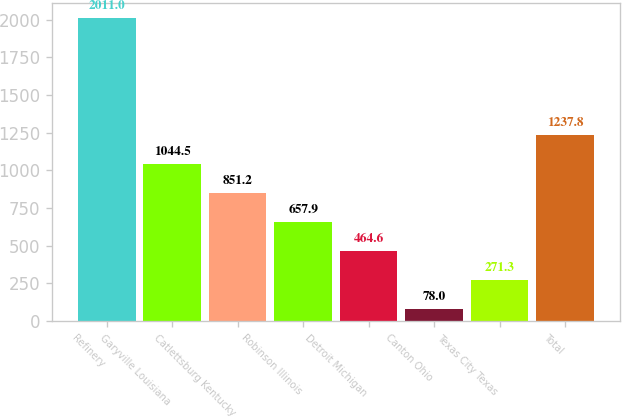Convert chart to OTSL. <chart><loc_0><loc_0><loc_500><loc_500><bar_chart><fcel>Refinery<fcel>Garyville Louisiana<fcel>Catlettsburg Kentucky<fcel>Robinson Illinois<fcel>Detroit Michigan<fcel>Canton Ohio<fcel>Texas City Texas<fcel>Total<nl><fcel>2011<fcel>1044.5<fcel>851.2<fcel>657.9<fcel>464.6<fcel>78<fcel>271.3<fcel>1237.8<nl></chart> 